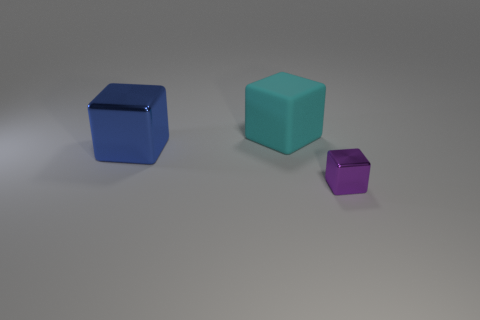Add 2 big metallic blocks. How many objects exist? 5 Add 1 purple blocks. How many purple blocks are left? 2 Add 2 metallic cubes. How many metallic cubes exist? 4 Subtract 0 purple cylinders. How many objects are left? 3 Subtract all large cyan objects. Subtract all purple things. How many objects are left? 1 